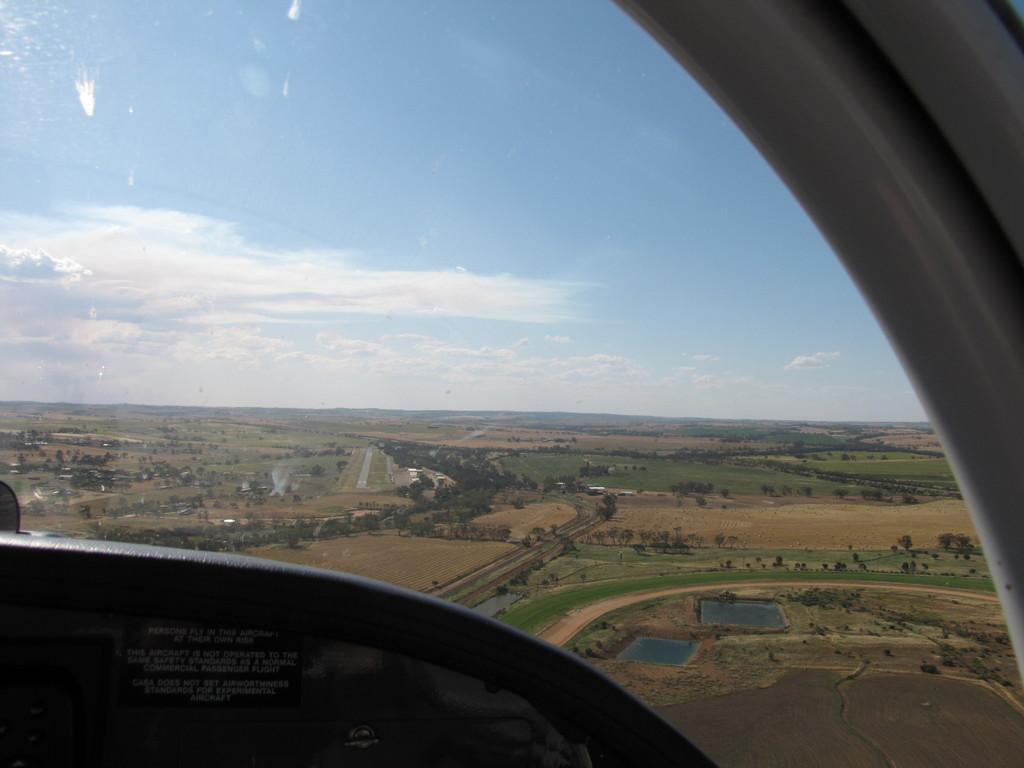What type of structure is visible in the image? The structure is a flying jet, as the window belongs to it. What can be seen through the window in the image? There is a path, water, grass, and trees visible outside the window. How would you describe the sky in the image? The sky is cloudy and pale blue. What type of disease is affecting the trees visible outside the window? There is no indication of any disease affecting the trees in the image; they appear to be healthy. Can you see any veins in the image? There are no veins visible in the image, as it features a window of a flying jet and the natural elements outside. 